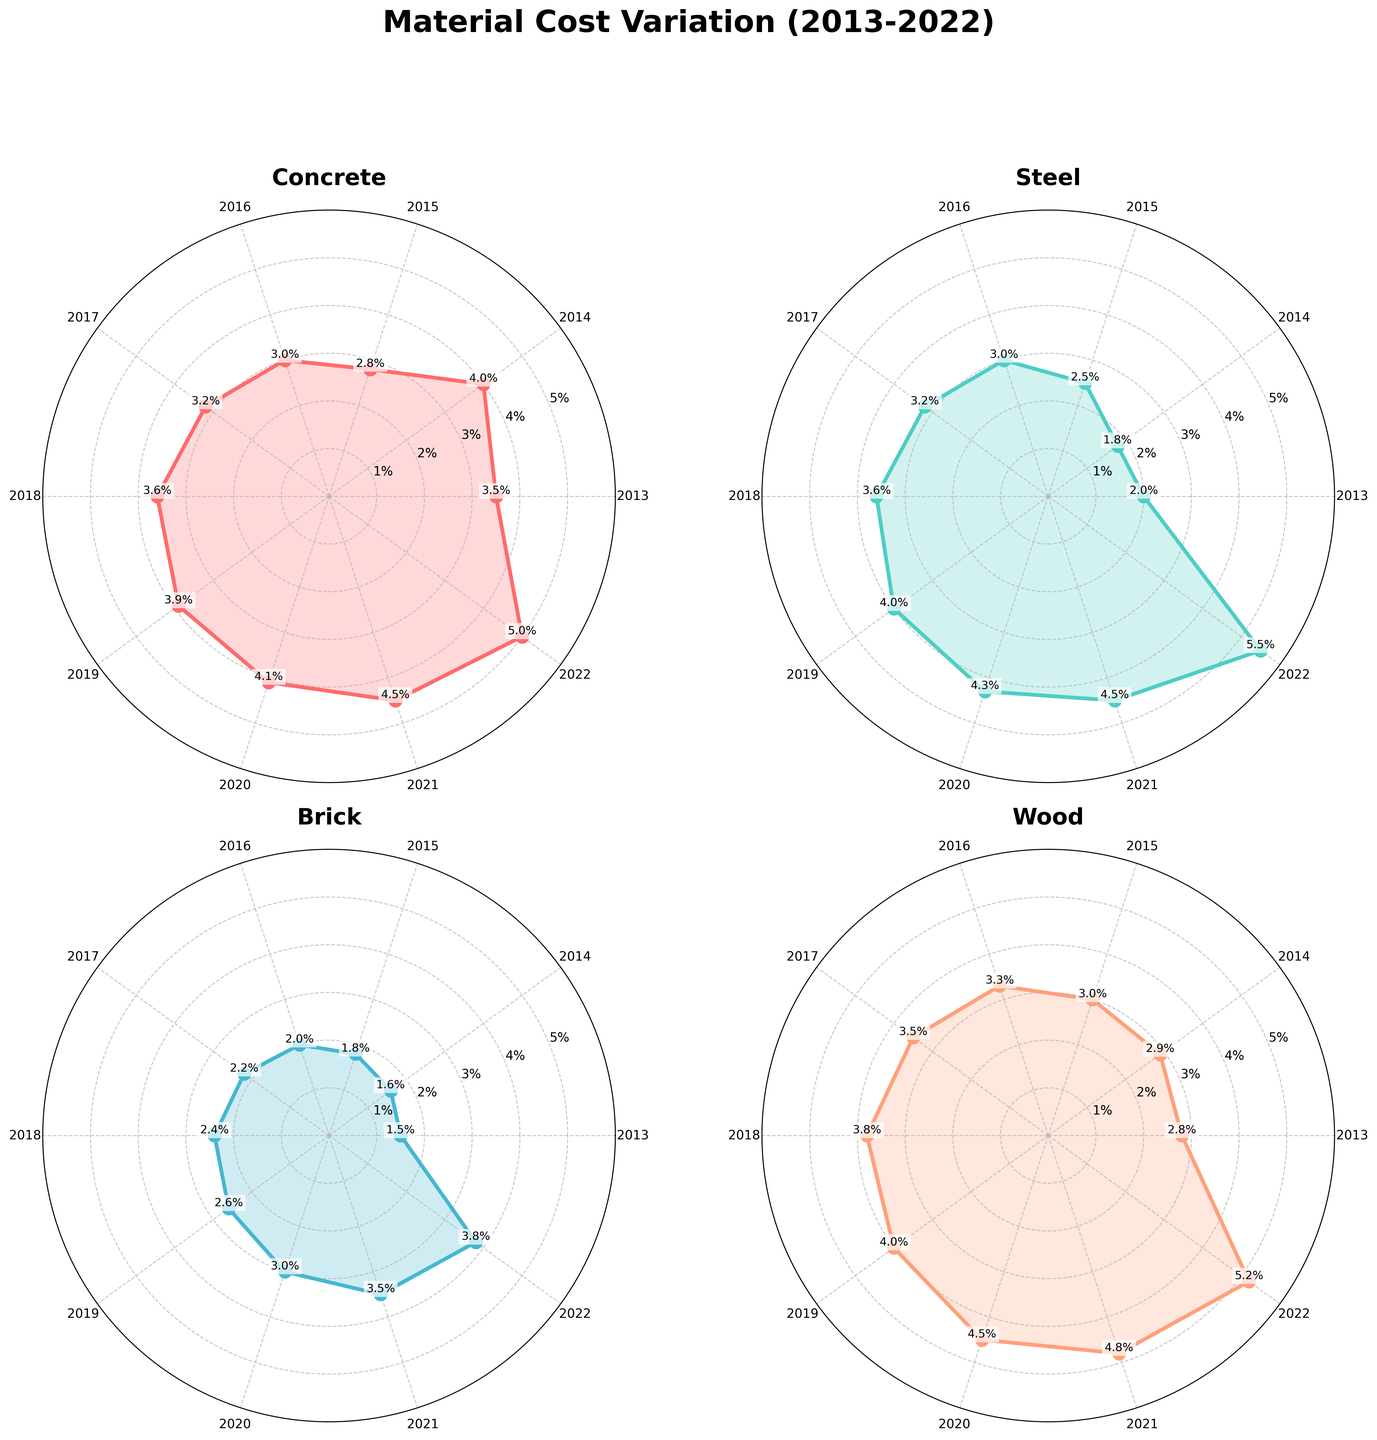What is the maximum variation percentage for Concrete? To find the maximum variation percentage for Concrete, locate the Polar Chart for Concrete and identify the highest value point. The maximum value is marked with text on the chart.
Answer: 5.0% How did the cost variation for Steel change from 2019 to 2020? Locate the points for 2019 and 2020 on the Steel Polar Chart. The variation percentage in 2019 was 4.0%, and in 2020 it was 4.3%. The change is calculated as 4.3% - 4.0%.
Answer: 0.3% increase During which year did Brick experience the lowest cost variation? Identify the point on the Brick Polar Chart with the lowest value. The chart marks the years, and the lowest marked percentage will indicate the year.
Answer: 2013 Compare the overall trends of cost variation between Wood and Concrete from 2013 to 2022. Look at both the Wood and Concrete Polar Charts. Both materials show an upward trend in cost variation. Compare the patterns and slopes in the plots to determine if one was more consistent or had steeper increments.
Answer: Both increased, but Wood saw a slightly steadier rise Which building material had the most significant variation percentage increase around the year 2020? On each Polar Chart, compare the steepness of the curve from 2019 to 2020. The steepest increase indicates the highest variation increase.
Answer: Steel What is the average cost variation for Wood over the decade? Sum up the variation percentages for Wood from 2013 to 2022 and then divide by 10, the number of years. The values are 2.8%, 2.9%, 3.0%, 3.3%, 3.5%, 3.8%, 4.0%, 4.5%, 4.8%, and 5.2%. The sum is 37.8% and the average is 37.8% / 10.
Answer: 3.78% Find the year when all materials, on average, had the closest cost variation percentages to each other. For each year, list and compare the variation percentages of Concrete, Steel, Brick, and Wood. Determine which year’s values are closest numerically. Calculate the variance for each year and identify the smallest variance.
Answer: 2017 Which building material had the steadiest increase in variation percentage from 2013 to 2022? Compare the curves for all materials: Concrete, Steel, Brick, and Wood. The progression of variation percentages from year to year should show the smallest changes. Look for uniform gaps between points on the Polar Chart.
Answer: Brick 